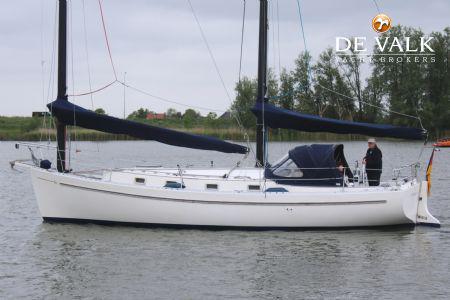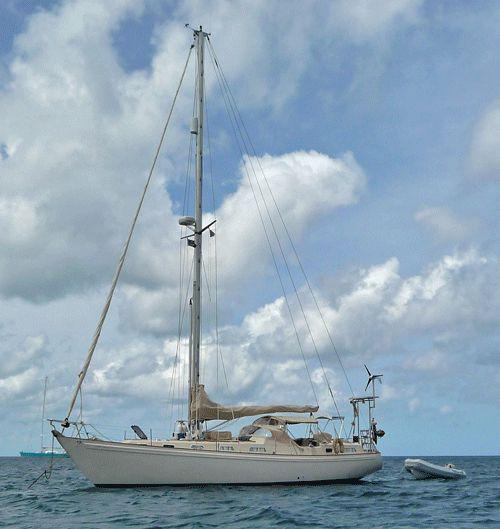The first image is the image on the left, the second image is the image on the right. Examine the images to the left and right. Is the description "The boat in the left image has a blue hull, and the boats in the left and right images have their sails in the same position [furled or unfurled]." accurate? Answer yes or no. No. 